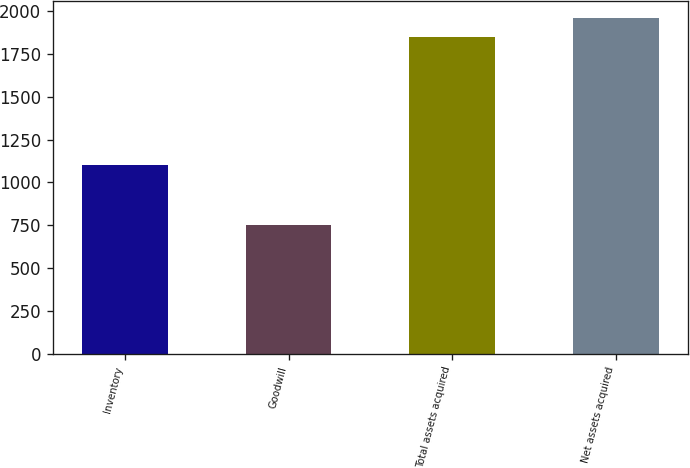Convert chart. <chart><loc_0><loc_0><loc_500><loc_500><bar_chart><fcel>Inventory<fcel>Goodwill<fcel>Total assets acquired<fcel>Net assets acquired<nl><fcel>1102<fcel>748<fcel>1850<fcel>1960.2<nl></chart> 